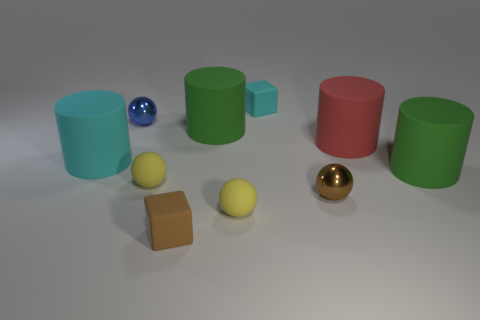Subtract all tiny brown shiny balls. How many balls are left? 3 Subtract all yellow spheres. How many spheres are left? 2 Subtract 3 cylinders. How many cylinders are left? 1 Subtract all spheres. How many objects are left? 6 Subtract 2 yellow spheres. How many objects are left? 8 Subtract all brown cubes. Subtract all blue balls. How many cubes are left? 1 Subtract all gray cubes. How many red cylinders are left? 1 Subtract all green things. Subtract all blue metal things. How many objects are left? 7 Add 5 small yellow balls. How many small yellow balls are left? 7 Add 8 brown shiny spheres. How many brown shiny spheres exist? 9 